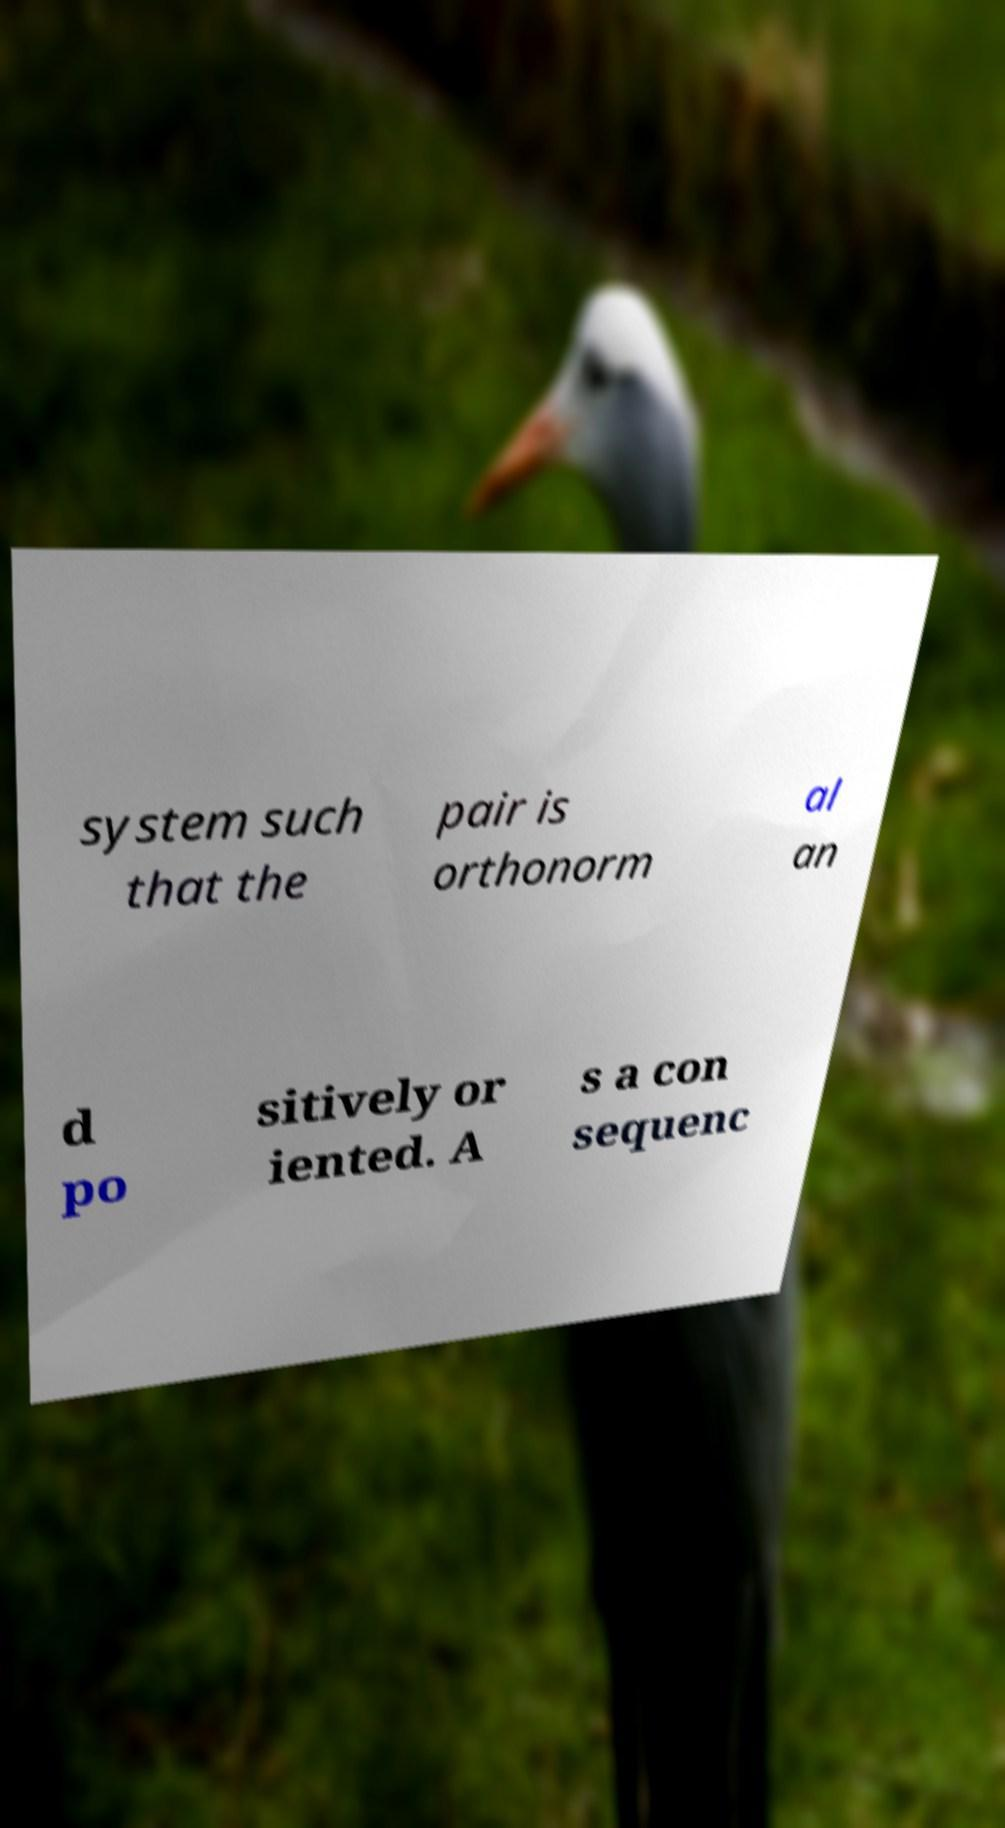Please identify and transcribe the text found in this image. system such that the pair is orthonorm al an d po sitively or iented. A s a con sequenc 